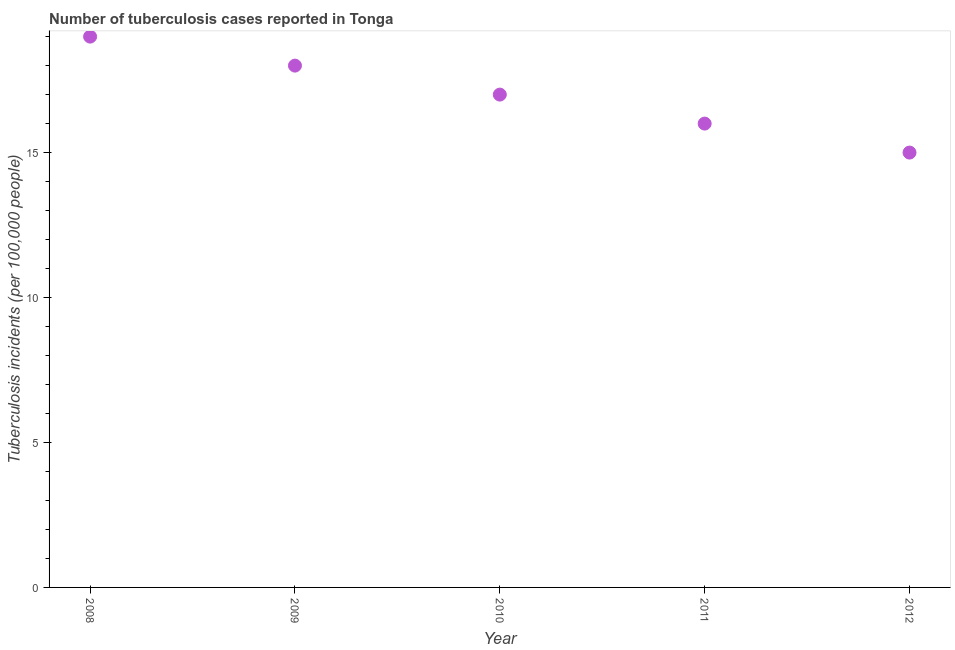What is the number of tuberculosis incidents in 2009?
Your answer should be compact. 18. Across all years, what is the maximum number of tuberculosis incidents?
Your answer should be very brief. 19. Across all years, what is the minimum number of tuberculosis incidents?
Offer a very short reply. 15. What is the sum of the number of tuberculosis incidents?
Your response must be concise. 85. What is the difference between the number of tuberculosis incidents in 2011 and 2012?
Your answer should be very brief. 1. What is the average number of tuberculosis incidents per year?
Make the answer very short. 17. What is the median number of tuberculosis incidents?
Your response must be concise. 17. Do a majority of the years between 2012 and 2010 (inclusive) have number of tuberculosis incidents greater than 10 ?
Your response must be concise. No. What is the ratio of the number of tuberculosis incidents in 2010 to that in 2011?
Provide a short and direct response. 1.06. Is the number of tuberculosis incidents in 2010 less than that in 2011?
Offer a terse response. No. What is the difference between the highest and the second highest number of tuberculosis incidents?
Provide a succinct answer. 1. Is the sum of the number of tuberculosis incidents in 2010 and 2011 greater than the maximum number of tuberculosis incidents across all years?
Your response must be concise. Yes. What is the difference between the highest and the lowest number of tuberculosis incidents?
Give a very brief answer. 4. What is the difference between two consecutive major ticks on the Y-axis?
Keep it short and to the point. 5. Does the graph contain grids?
Give a very brief answer. No. What is the title of the graph?
Your answer should be very brief. Number of tuberculosis cases reported in Tonga. What is the label or title of the X-axis?
Provide a short and direct response. Year. What is the label or title of the Y-axis?
Your answer should be very brief. Tuberculosis incidents (per 100,0 people). What is the Tuberculosis incidents (per 100,000 people) in 2009?
Provide a succinct answer. 18. What is the Tuberculosis incidents (per 100,000 people) in 2010?
Ensure brevity in your answer.  17. What is the Tuberculosis incidents (per 100,000 people) in 2011?
Provide a succinct answer. 16. What is the difference between the Tuberculosis incidents (per 100,000 people) in 2008 and 2009?
Your response must be concise. 1. What is the difference between the Tuberculosis incidents (per 100,000 people) in 2008 and 2010?
Keep it short and to the point. 2. What is the difference between the Tuberculosis incidents (per 100,000 people) in 2008 and 2012?
Make the answer very short. 4. What is the difference between the Tuberculosis incidents (per 100,000 people) in 2009 and 2010?
Give a very brief answer. 1. What is the difference between the Tuberculosis incidents (per 100,000 people) in 2009 and 2011?
Your answer should be very brief. 2. What is the difference between the Tuberculosis incidents (per 100,000 people) in 2010 and 2011?
Offer a terse response. 1. What is the difference between the Tuberculosis incidents (per 100,000 people) in 2010 and 2012?
Make the answer very short. 2. What is the ratio of the Tuberculosis incidents (per 100,000 people) in 2008 to that in 2009?
Give a very brief answer. 1.06. What is the ratio of the Tuberculosis incidents (per 100,000 people) in 2008 to that in 2010?
Offer a very short reply. 1.12. What is the ratio of the Tuberculosis incidents (per 100,000 people) in 2008 to that in 2011?
Your answer should be compact. 1.19. What is the ratio of the Tuberculosis incidents (per 100,000 people) in 2008 to that in 2012?
Keep it short and to the point. 1.27. What is the ratio of the Tuberculosis incidents (per 100,000 people) in 2009 to that in 2010?
Your answer should be very brief. 1.06. What is the ratio of the Tuberculosis incidents (per 100,000 people) in 2009 to that in 2011?
Give a very brief answer. 1.12. What is the ratio of the Tuberculosis incidents (per 100,000 people) in 2010 to that in 2011?
Provide a succinct answer. 1.06. What is the ratio of the Tuberculosis incidents (per 100,000 people) in 2010 to that in 2012?
Make the answer very short. 1.13. What is the ratio of the Tuberculosis incidents (per 100,000 people) in 2011 to that in 2012?
Provide a short and direct response. 1.07. 